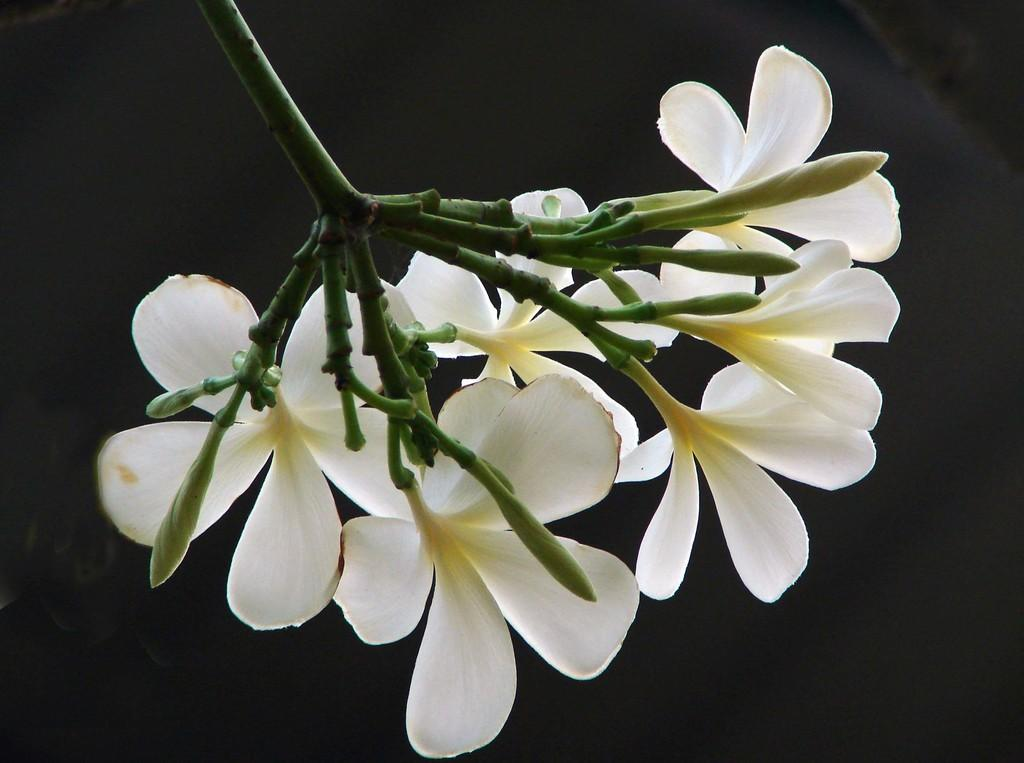What type of living organisms can be seen in the image? Flowers can be seen in the image. How many clocks are present in the image? There are no clocks present in the image; it only features flowers. 